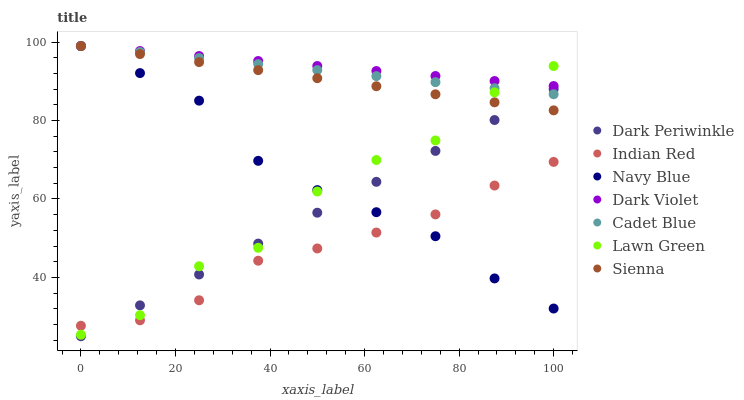Does Indian Red have the minimum area under the curve?
Answer yes or no. Yes. Does Dark Violet have the maximum area under the curve?
Answer yes or no. Yes. Does Cadet Blue have the minimum area under the curve?
Answer yes or no. No. Does Cadet Blue have the maximum area under the curve?
Answer yes or no. No. Is Dark Violet the smoothest?
Answer yes or no. Yes. Is Lawn Green the roughest?
Answer yes or no. Yes. Is Cadet Blue the smoothest?
Answer yes or no. No. Is Cadet Blue the roughest?
Answer yes or no. No. Does Dark Periwinkle have the lowest value?
Answer yes or no. Yes. Does Cadet Blue have the lowest value?
Answer yes or no. No. Does Sienna have the highest value?
Answer yes or no. Yes. Does Indian Red have the highest value?
Answer yes or no. No. Is Dark Periwinkle less than Dark Violet?
Answer yes or no. Yes. Is Sienna greater than Indian Red?
Answer yes or no. Yes. Does Lawn Green intersect Cadet Blue?
Answer yes or no. Yes. Is Lawn Green less than Cadet Blue?
Answer yes or no. No. Is Lawn Green greater than Cadet Blue?
Answer yes or no. No. Does Dark Periwinkle intersect Dark Violet?
Answer yes or no. No. 